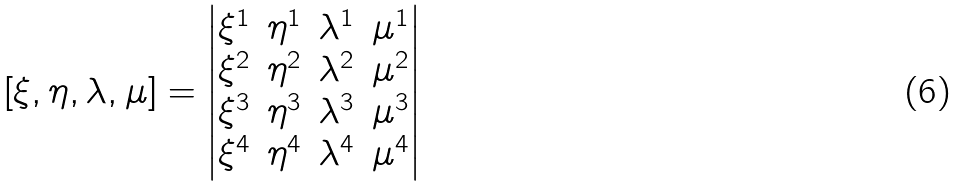Convert formula to latex. <formula><loc_0><loc_0><loc_500><loc_500>[ \xi , \eta , \lambda , \mu ] = \begin{vmatrix} \xi ^ { 1 } & \eta ^ { 1 } & \lambda ^ { 1 } & \mu ^ { 1 } \\ \xi ^ { 2 } & \eta ^ { 2 } & \lambda ^ { 2 } & \mu ^ { 2 } \\ \xi ^ { 3 } & \eta ^ { 3 } & \lambda ^ { 3 } & \mu ^ { 3 } \\ \xi ^ { 4 } & \eta ^ { 4 } & \lambda ^ { 4 } & \mu ^ { 4 } \end{vmatrix}</formula> 